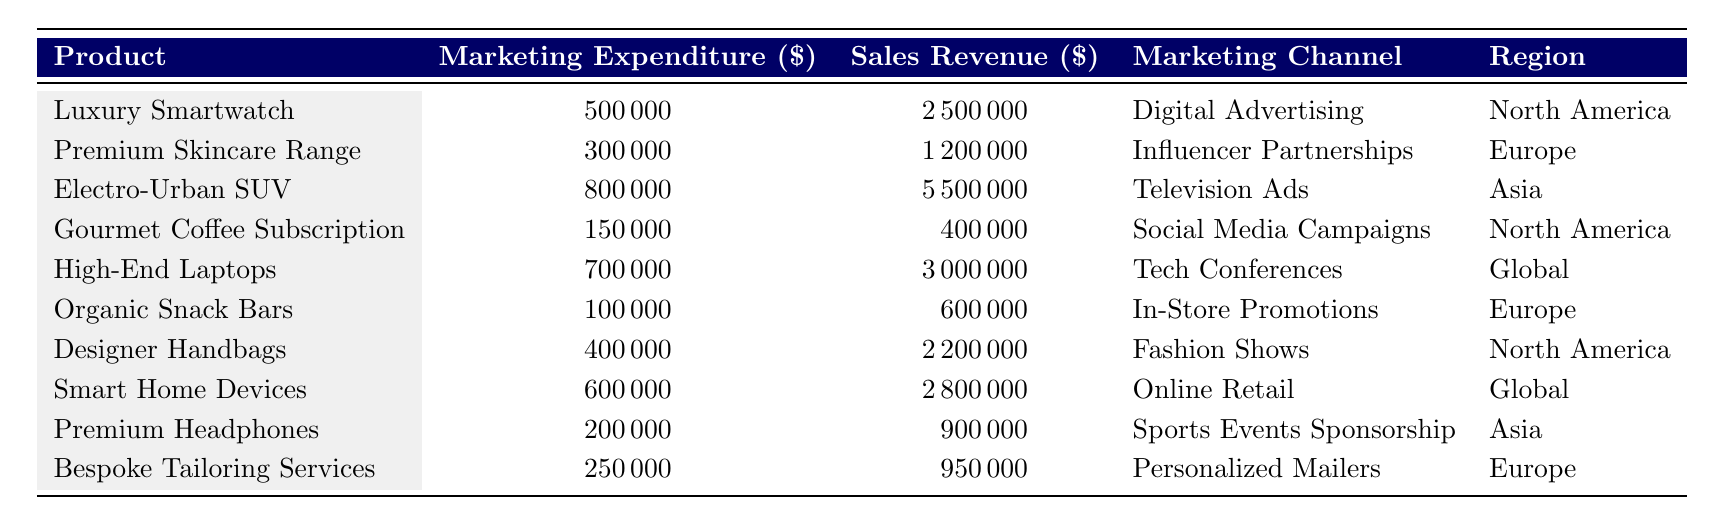What is the marketing expenditure for the Electro-Urban SUV? The table shows a direct entry for the Electro-Urban SUV with a marketing expenditure of 800,000.
Answer: 800,000 Which product line has the highest sales revenue? By comparing the sales revenue, the Electro-Urban SUV has the highest value at 5,500,000.
Answer: Electro-Urban SUV What is the total marketing expenditure across all product lines? The marketing expenditures are summed: 500,000 + 300,000 + 800,000 + 150,000 + 700,000 + 100,000 + 400,000 + 600,000 + 200,000 + 250,000 = 3,650,000.
Answer: 3,650,000 Is the marketing channel for Luxury Smartwatch Digital Advertising? The table clearly states that the marketing channel for Luxury Smartwatch is indeed Digital Advertising.
Answer: Yes What is the average sales revenue of the product lines? The sales revenues are summed: 2,500,000 + 1,200,000 + 5,500,000 + 400,000 + 3,000,000 + 600,000 + 2,200,000 + 2,800,000 + 900,000 + 950,000 = 20,650,000. There are 10 product lines, so the average is 20,650,000 / 10 = 2,065,000.
Answer: 2,065,000 How much more was spent on marketing for High-End Laptops compared to Organic Snack Bars? The difference in marketing expenditure is calculated: 700,000 (High-End Laptops) - 100,000 (Organic Snack Bars) = 600,000.
Answer: 600,000 Which region has the highest marketing spending on its products? Summing the marketing expenditures by region: North America (500,000 + 150,000 + 400,000), Europe (300,000 + 100,000 + 250,000), Asia (800,000 + 200,000), and Global (700,000 + 600,000). North America = 1,050,000; Europe = 650,000; Asia = 1,000,000; Global = 1,300,000. Thus, Global has the highest expenditure at 1,300,000.
Answer: Global What is the ratio of marketing expenditure to sales revenue for the Designer Handbags? The ratio is calculated as marketing expenditure (400,000) divided by sales revenue (2,200,000). This equals 400,000 / 2,200,000 = 0.1818.
Answer: 0.1818 Does the Gourmet Coffee Subscription have a higher or lower sales revenue than the Premium Skincare Range? The sales revenue for Gourmet Coffee Subscription is 400,000, while for Premium Skincare Range it is 1,200,000. Therefore, it is lower.
Answer: Lower 